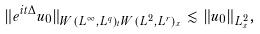<formula> <loc_0><loc_0><loc_500><loc_500>\| e ^ { i t \Delta } u _ { 0 } \| _ { W ( L ^ { \infty } , L ^ { q } ) _ { t } W ( L ^ { 2 } , L ^ { r } ) _ { x } } \lesssim \| u _ { 0 } \| _ { L ^ { 2 } _ { x } } ,</formula> 